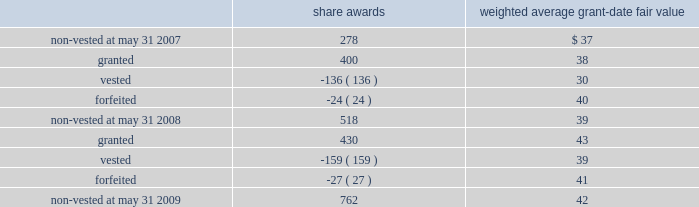Notes to consolidated financial statements 2014 ( continued ) the table summarizes the changes in non-vested restricted stock awards for the year ended may 31 , 2009 ( share awards in thousands ) : share awards weighted average grant-date fair value .
The weighted average grant-date fair value of share awards granted in the years ended may 31 , 2008 and 2007 was $ 38 and $ 45 , respectively .
The total fair value of share awards vested during the years ended may 31 , 2009 , 2008 and 2007 was $ 6.2 million , $ 4.1 million and $ 1.7 million , respectively .
We recognized compensation expense for restricted stock of $ 9.0 million , $ 5.7 million , and $ 2.7 million in the years ended may 31 , 2009 , 2008 and 2007 .
As of may 31 , 2009 , there was $ 23.5 million of total unrecognized compensation cost related to unvested restricted stock awards that is expected to be recognized over a weighted average period of 2.9 years .
Employee stock purchase plan we have an employee stock purchase plan under which the sale of 2.4 million shares of our common stock has been authorized .
Employees may designate up to the lesser of $ 25000 or 20% ( 20 % ) of their annual compensation for the purchase of stock .
The price for shares purchased under the plan is 85% ( 85 % ) of the market value on the last day of the quarterly purchase period .
As of may 31 , 2009 , 0.8 million shares had been issued under this plan , with 1.6 million shares reserved for future issuance .
The weighted average grant-date fair value of each designated share purchased under this plan was $ 6 , $ 6 and $ 8 in the years ended may 31 , 2009 , 2008 and 2007 , respectively .
These values represent the fair value of the 15% ( 15 % ) discount .
Note 12 2014segment information general information during fiscal 2009 , we began assessing our operating performance using a new segment structure .
We made this change as a result of our june 30 , 2008 acquisition of 51% ( 51 % ) of hsbc merchant services llp in the united kingdom , in addition to anticipated future international expansion .
Beginning with the quarter ended august 31 , 2008 , the reportable segments are defined as north america merchant services , international merchant services , and money transfer .
The following tables reflect these changes and such reportable segments for fiscal years 2009 , 2008 , and 2007. .
What is an employees total annual compensation? 
Rationale: the company gives their employees an annual compensation of $ 125000 . this is found by dividing $ 25000 used for stock buying by 20% .
Computations: (25000 / 20%)
Answer: 125000.0. 